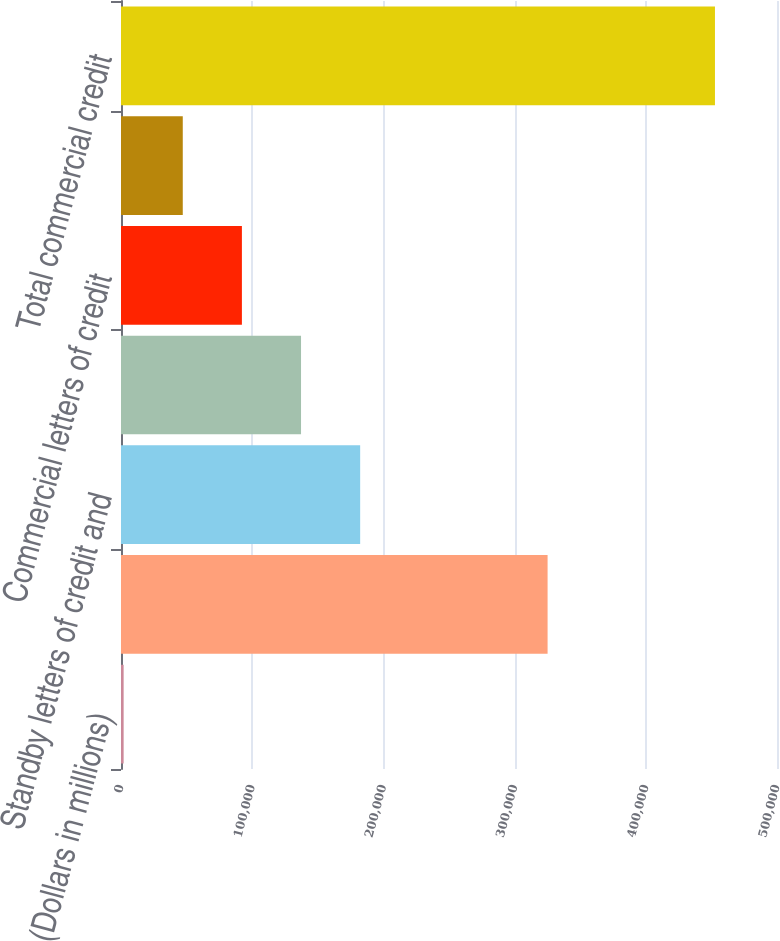Convert chart to OTSL. <chart><loc_0><loc_0><loc_500><loc_500><bar_chart><fcel>(Dollars in millions)<fcel>Loans and leases<fcel>Standby letters of credit and<fcel>Assets held-for-sale (6)<fcel>Commercial letters of credit<fcel>Bankers' acceptances<fcel>Total commercial credit<nl><fcel>2007<fcel>325143<fcel>182291<fcel>137220<fcel>92148.8<fcel>47077.9<fcel>452716<nl></chart> 